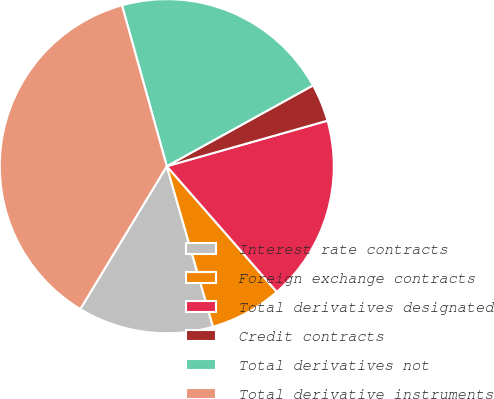Convert chart to OTSL. <chart><loc_0><loc_0><loc_500><loc_500><pie_chart><fcel>Interest rate contracts<fcel>Foreign exchange contracts<fcel>Total derivatives designated<fcel>Credit contracts<fcel>Total derivatives not<fcel>Total derivative instruments<nl><fcel>13.13%<fcel>6.98%<fcel>17.95%<fcel>3.64%<fcel>21.29%<fcel>37.01%<nl></chart> 